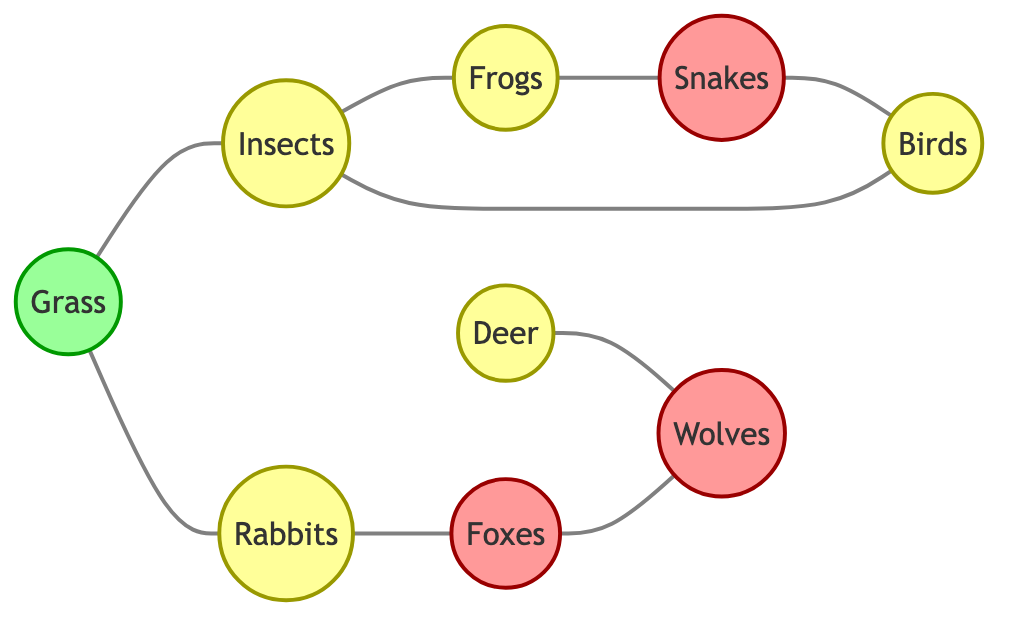What are the two plants represented in the diagram? The diagram shows "Grass" and "Deer" as the two plant nodes, but "Deer" is not a plant in the food chain; it is a prey. Therefore, the answer is "Grass".
Answer: Grass How many predator nodes are present in the diagram? The predator nodes are "Snakes", "Foxes", and "Wolves". Counting these gives us a total of 3 predator nodes.
Answer: 3 Which animal is a common prey for both "Snakes" and "Foxes"? Looking at the edges, "Birds" are connected to both "Snakes" and another predator node "Wolves", while "Rabbits" connect only with "Foxes". The answer is "Birds".
Answer: Birds How many total edges are there in the diagram? Counting the connections (edges) between nodes, there are 9 connections shown in the diagram.
Answer: 9 Which two animals are directly connected to "Grass"? The diagram shows connections from "Grass" to "Insects" and "Rabbits". Thus, the two animals are "Insects" and "Rabbits".
Answer: Insects, Rabbits Which animal is at the top of the food chain in this diagram? "Wolves" is the only predator that does not have any edges leading out to other nodes, indicating that it is at the top of the food chain in this ecosystem.
Answer: Wolves What type of node is "Insects"? Referring to the type classifications in the diagram, "Insects" is classified as a prey node.
Answer: Prey How many connections does "Foxes" have? "Foxes" is connected to two nodes: "Rabbits" (prey) and "Wolves" (predator). Therefore, it has 2 connections.
Answer: 2 Which animal has no edges connected to "Frogs"? Checking the edges from "Frogs", they connect only to "Snakes". Therefore, animals like "Deer", "Foxes", and "Wolves" have no direct connection to "Frogs". However, the specific animal we can name is "Foxes".
Answer: Foxes 